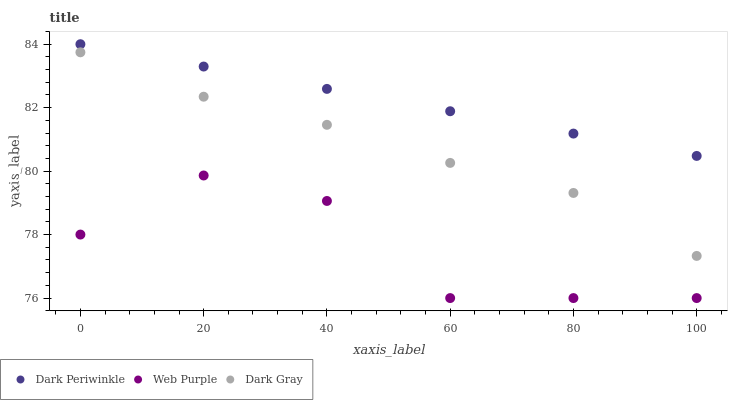Does Web Purple have the minimum area under the curve?
Answer yes or no. Yes. Does Dark Periwinkle have the maximum area under the curve?
Answer yes or no. Yes. Does Dark Periwinkle have the minimum area under the curve?
Answer yes or no. No. Does Web Purple have the maximum area under the curve?
Answer yes or no. No. Is Dark Periwinkle the smoothest?
Answer yes or no. Yes. Is Web Purple the roughest?
Answer yes or no. Yes. Is Web Purple the smoothest?
Answer yes or no. No. Is Dark Periwinkle the roughest?
Answer yes or no. No. Does Web Purple have the lowest value?
Answer yes or no. Yes. Does Dark Periwinkle have the lowest value?
Answer yes or no. No. Does Dark Periwinkle have the highest value?
Answer yes or no. Yes. Does Web Purple have the highest value?
Answer yes or no. No. Is Dark Gray less than Dark Periwinkle?
Answer yes or no. Yes. Is Dark Gray greater than Web Purple?
Answer yes or no. Yes. Does Dark Gray intersect Dark Periwinkle?
Answer yes or no. No. 